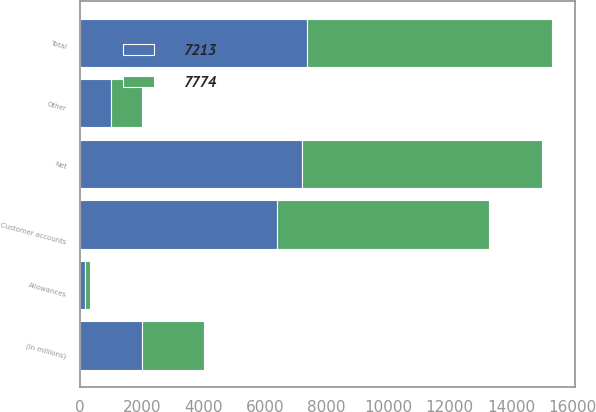<chart> <loc_0><loc_0><loc_500><loc_500><stacked_bar_chart><ecel><fcel>(In millions)<fcel>Customer accounts<fcel>Other<fcel>Total<fcel>Allowances<fcel>Net<nl><fcel>7774<fcel>2009<fcel>6902<fcel>1033<fcel>7935<fcel>161<fcel>7774<nl><fcel>7213<fcel>2008<fcel>6390<fcel>984<fcel>7374<fcel>161<fcel>7213<nl></chart> 